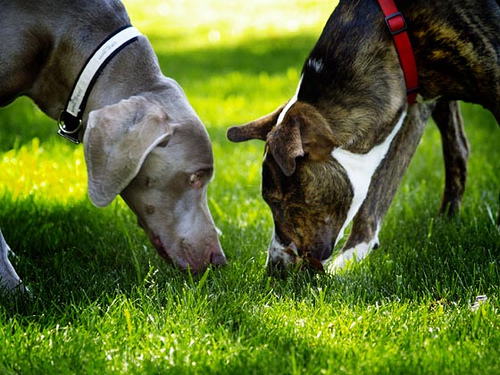<image>
Can you confirm if the dog is next to the grass? No. The dog is not positioned next to the grass. They are located in different areas of the scene. 